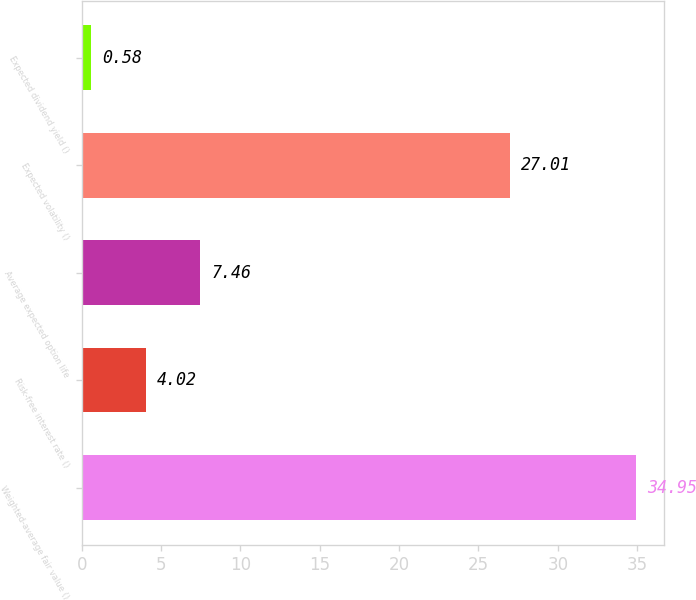Convert chart. <chart><loc_0><loc_0><loc_500><loc_500><bar_chart><fcel>Weighted-average fair value ()<fcel>Risk-free interest rate ()<fcel>Average expected option life<fcel>Expected volatility ()<fcel>Expected dividend yield ()<nl><fcel>34.95<fcel>4.02<fcel>7.46<fcel>27.01<fcel>0.58<nl></chart> 